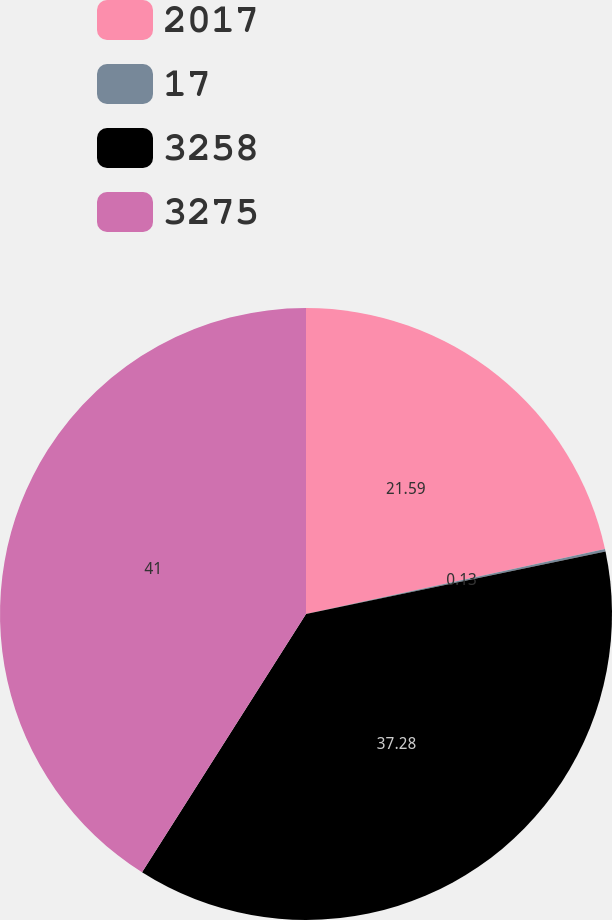Convert chart to OTSL. <chart><loc_0><loc_0><loc_500><loc_500><pie_chart><fcel>2017<fcel>17<fcel>3258<fcel>3275<nl><fcel>21.59%<fcel>0.13%<fcel>37.28%<fcel>41.0%<nl></chart> 